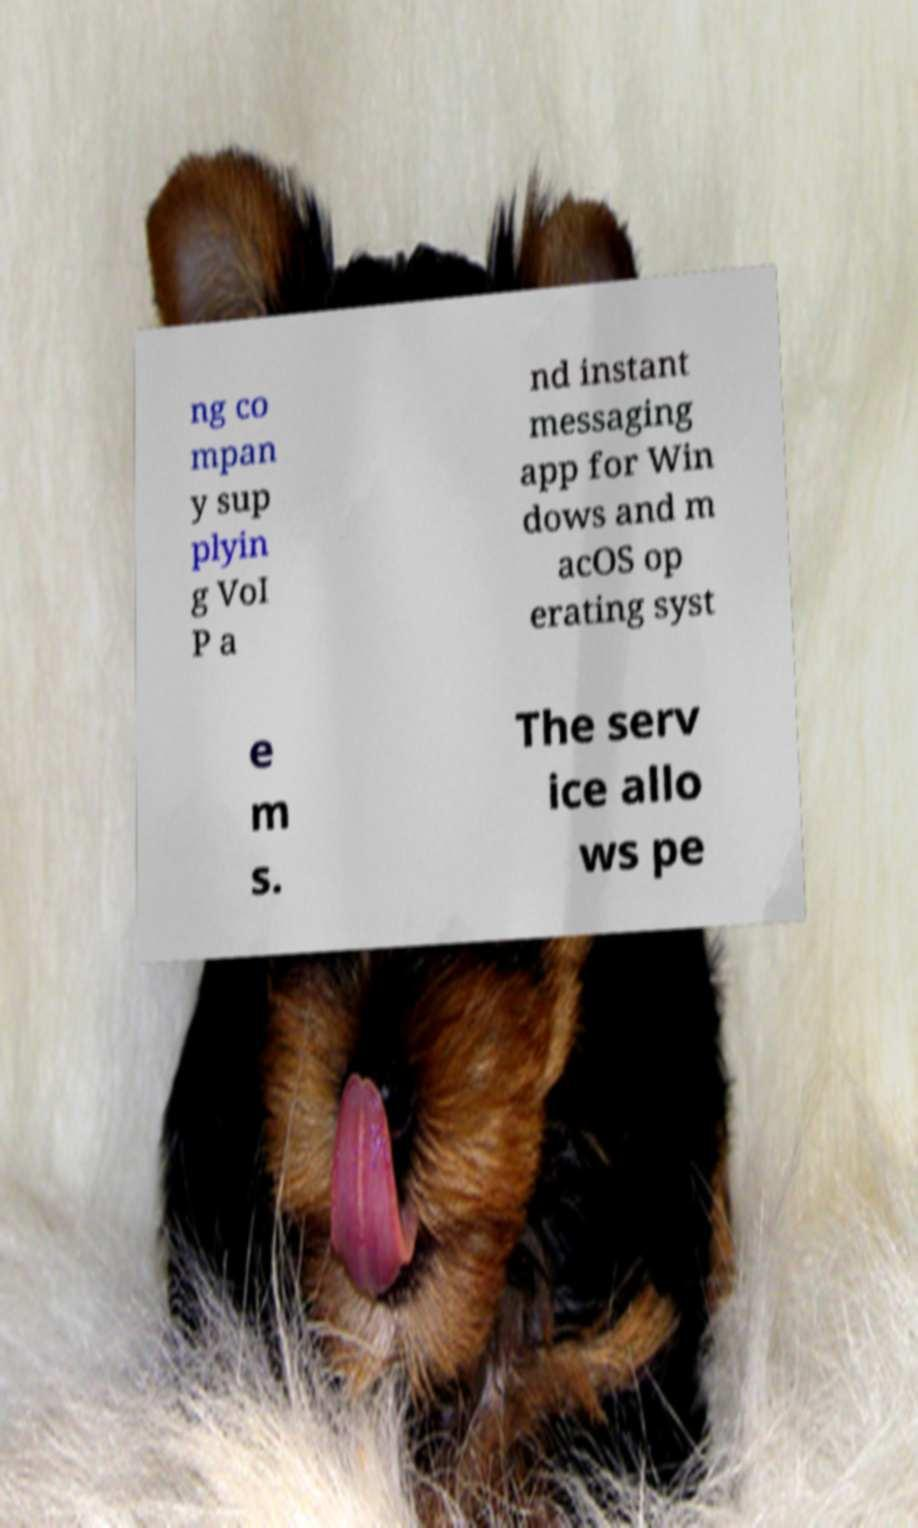Please read and relay the text visible in this image. What does it say? ng co mpan y sup plyin g VoI P a nd instant messaging app for Win dows and m acOS op erating syst e m s. The serv ice allo ws pe 